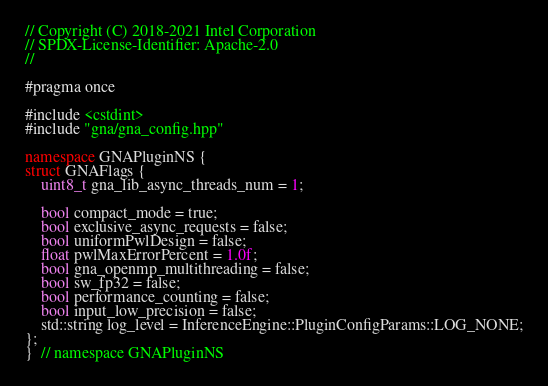<code> <loc_0><loc_0><loc_500><loc_500><_C++_>// Copyright (C) 2018-2021 Intel Corporation
// SPDX-License-Identifier: Apache-2.0
//

#pragma once

#include <cstdint>
#include "gna/gna_config.hpp"

namespace GNAPluginNS {
struct GNAFlags {
    uint8_t gna_lib_async_threads_num = 1;

    bool compact_mode = true;
    bool exclusive_async_requests = false;
    bool uniformPwlDesign = false;
    float pwlMaxErrorPercent = 1.0f;
    bool gna_openmp_multithreading = false;
    bool sw_fp32 = false;
    bool performance_counting = false;
    bool input_low_precision = false;
    std::string log_level = InferenceEngine::PluginConfigParams::LOG_NONE;
};
}  // namespace GNAPluginNS
</code> 